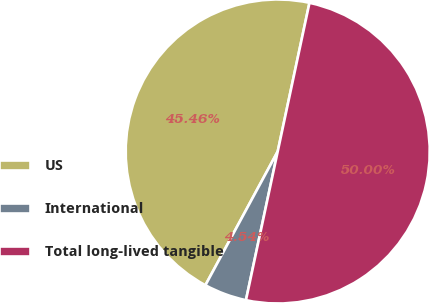Convert chart to OTSL. <chart><loc_0><loc_0><loc_500><loc_500><pie_chart><fcel>US<fcel>International<fcel>Total long-lived tangible<nl><fcel>45.46%<fcel>4.54%<fcel>50.0%<nl></chart> 